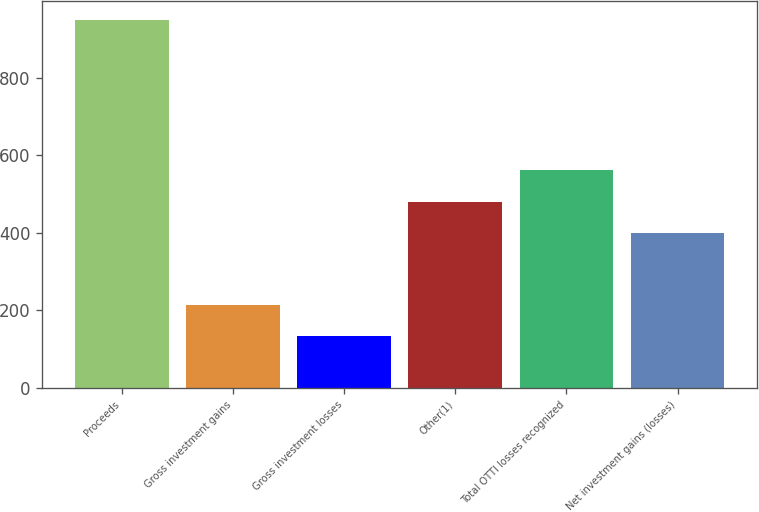Convert chart to OTSL. <chart><loc_0><loc_0><loc_500><loc_500><bar_chart><fcel>Proceeds<fcel>Gross investment gains<fcel>Gross investment losses<fcel>Other(1)<fcel>Total OTTI losses recognized<fcel>Net investment gains (losses)<nl><fcel>950<fcel>214.7<fcel>133<fcel>480.7<fcel>562.4<fcel>399<nl></chart> 